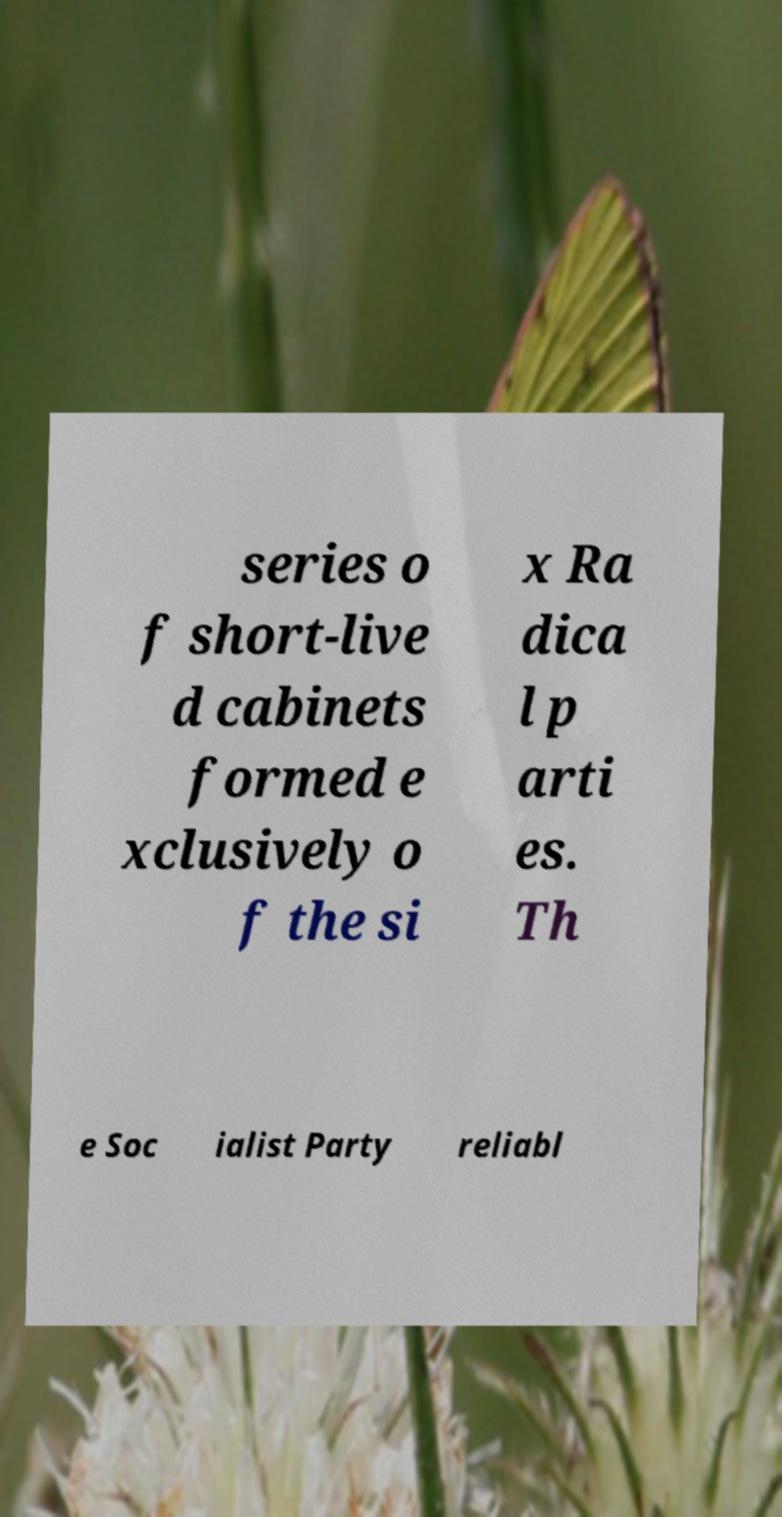What messages or text are displayed in this image? I need them in a readable, typed format. series o f short-live d cabinets formed e xclusively o f the si x Ra dica l p arti es. Th e Soc ialist Party reliabl 